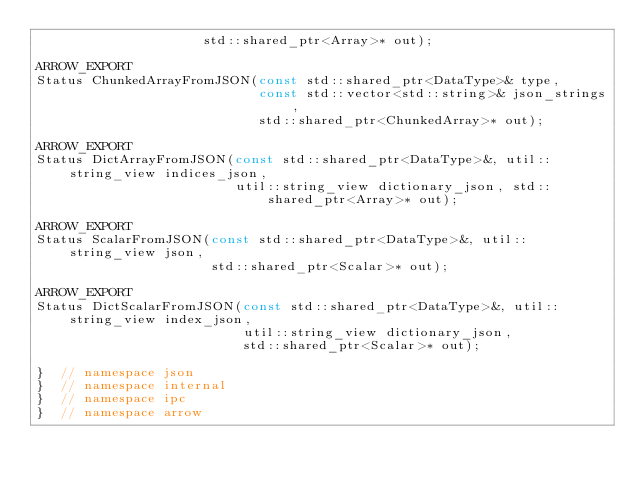Convert code to text. <code><loc_0><loc_0><loc_500><loc_500><_C_>                     std::shared_ptr<Array>* out);

ARROW_EXPORT
Status ChunkedArrayFromJSON(const std::shared_ptr<DataType>& type,
                            const std::vector<std::string>& json_strings,
                            std::shared_ptr<ChunkedArray>* out);

ARROW_EXPORT
Status DictArrayFromJSON(const std::shared_ptr<DataType>&, util::string_view indices_json,
                         util::string_view dictionary_json, std::shared_ptr<Array>* out);

ARROW_EXPORT
Status ScalarFromJSON(const std::shared_ptr<DataType>&, util::string_view json,
                      std::shared_ptr<Scalar>* out);

ARROW_EXPORT
Status DictScalarFromJSON(const std::shared_ptr<DataType>&, util::string_view index_json,
                          util::string_view dictionary_json,
                          std::shared_ptr<Scalar>* out);

}  // namespace json
}  // namespace internal
}  // namespace ipc
}  // namespace arrow
</code> 